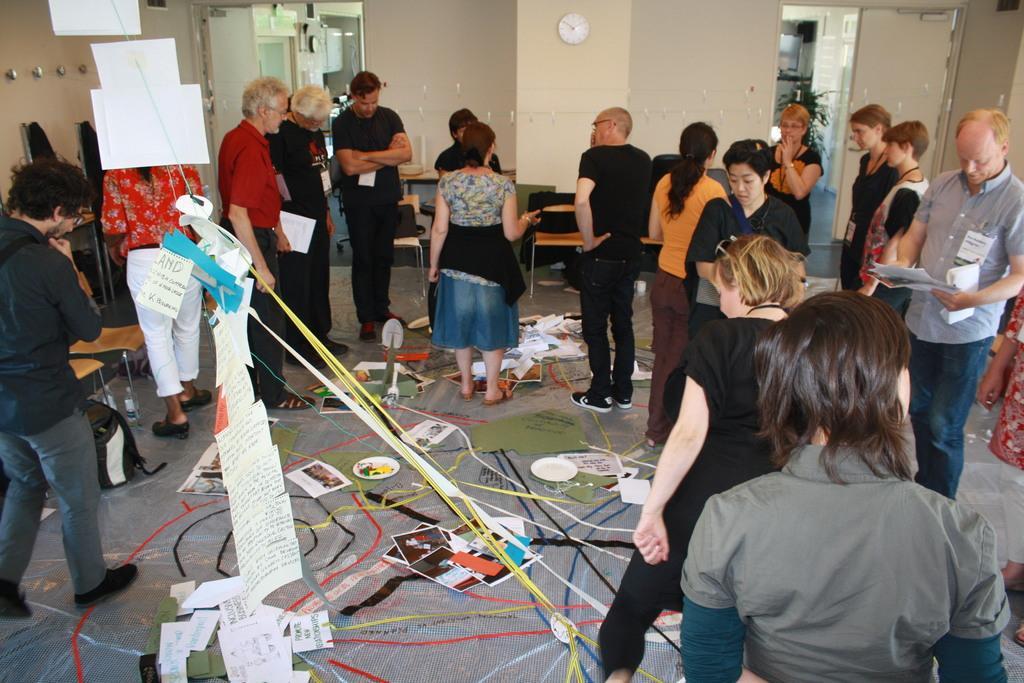Could you give a brief overview of what you see in this image? In this image, we can see some people standing and we can see some papers, cables. In the background, we can see the wall and we can see a clock on the wall. 